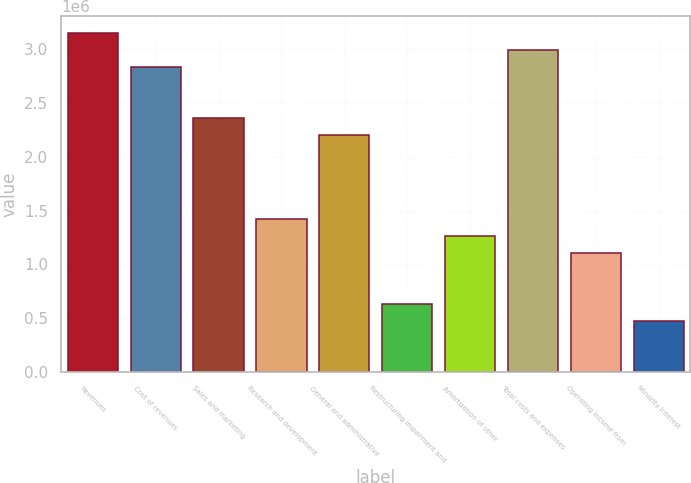Convert chart. <chart><loc_0><loc_0><loc_500><loc_500><bar_chart><fcel>Revenues<fcel>Cost of revenues<fcel>Sales and marketing<fcel>Research and development<fcel>General and administrative<fcel>Restructuring impairment and<fcel>Amortization of other<fcel>Total costs and expenses<fcel>Operating income from<fcel>Minority interest<nl><fcel>3.1505e+06<fcel>2.83545e+06<fcel>2.36287e+06<fcel>1.41772e+06<fcel>2.20535e+06<fcel>630101<fcel>1.2602e+06<fcel>2.99297e+06<fcel>1.10267e+06<fcel>472576<nl></chart> 